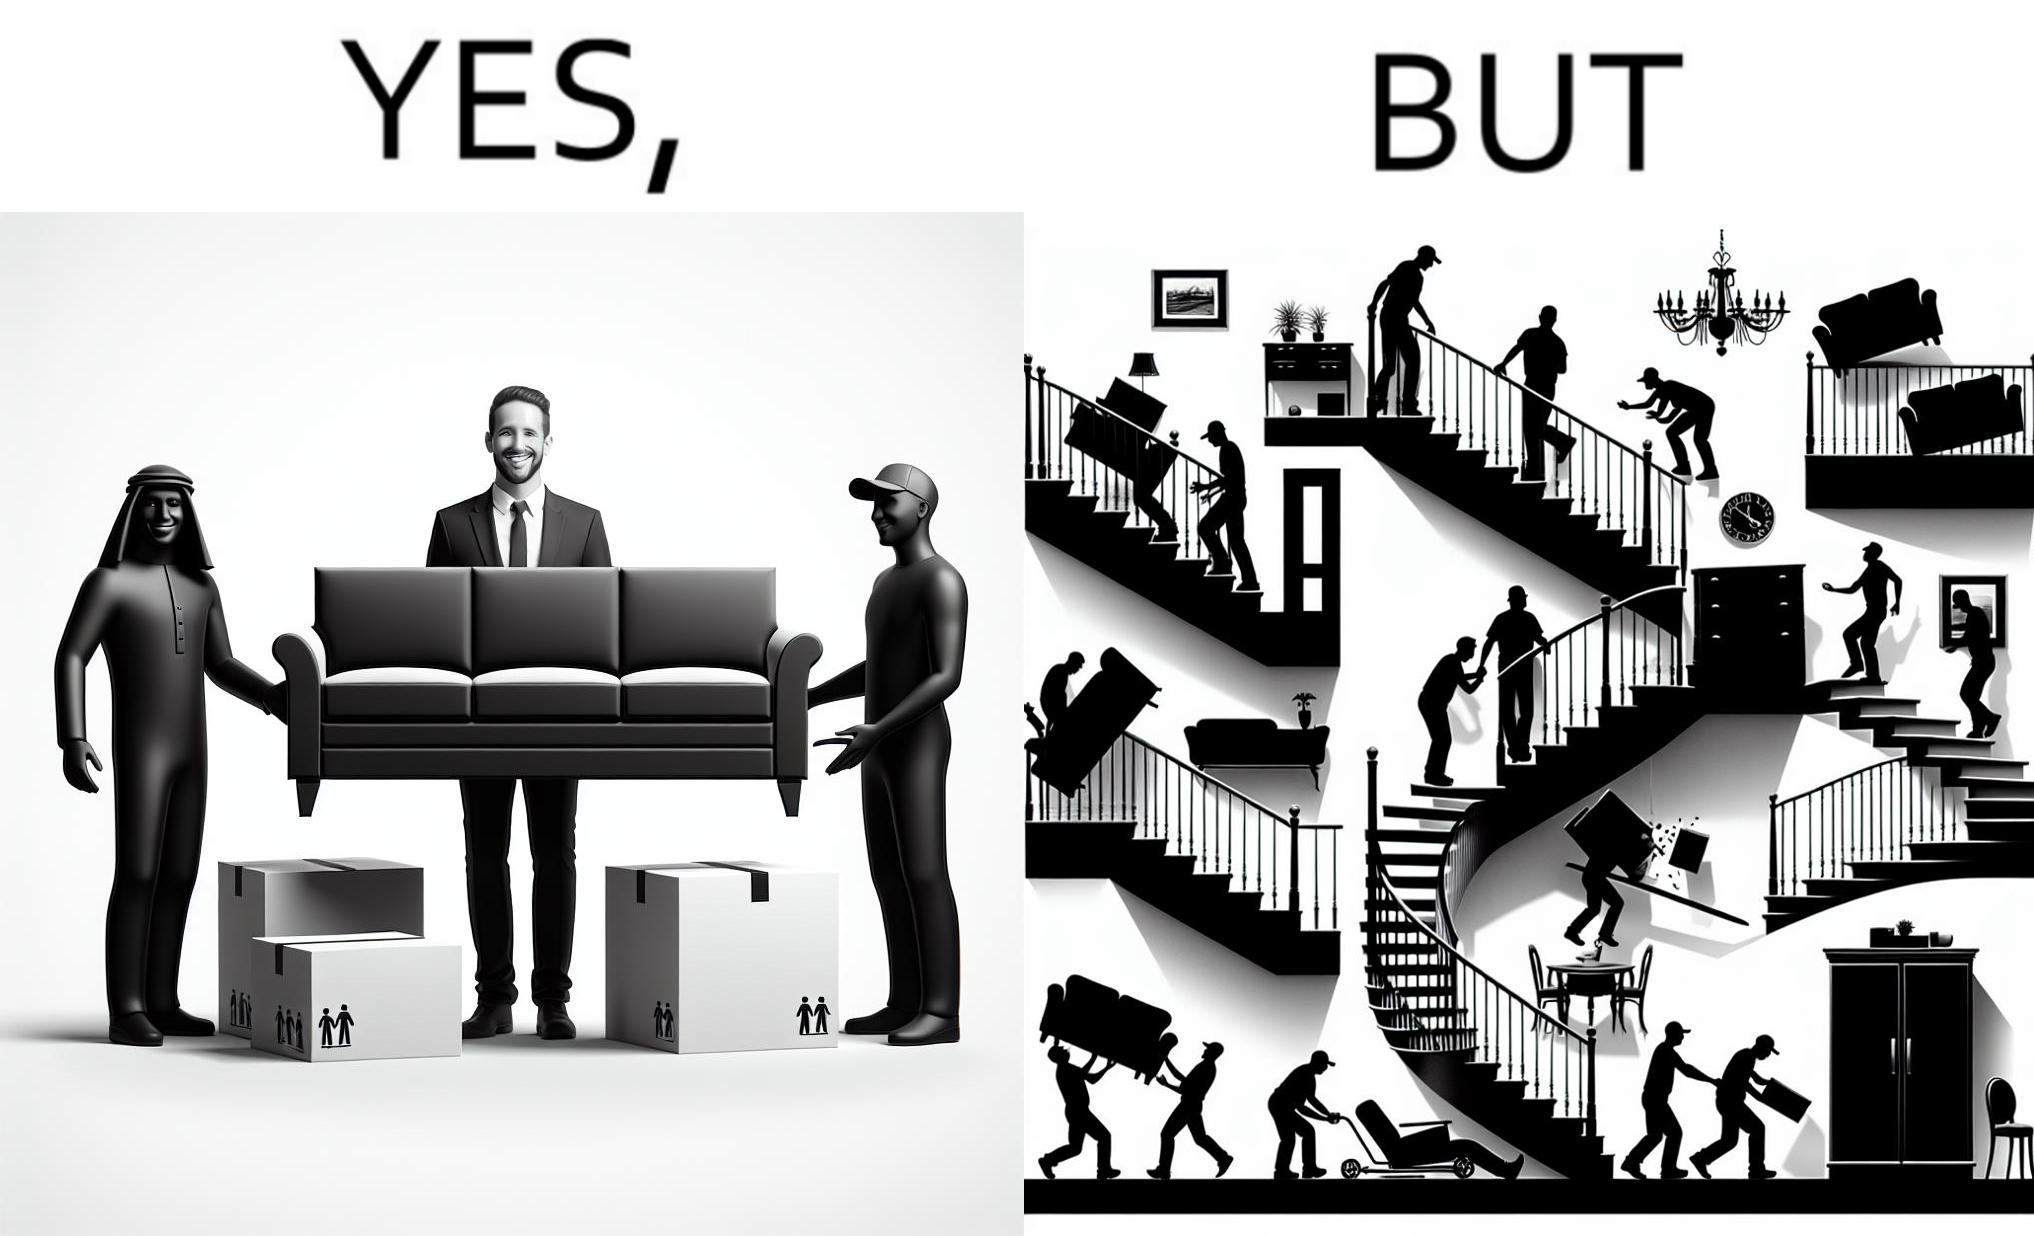Explain the humor or irony in this image. The images are funny since they show how even though the hired movers achieve their task of moving in furniture, in the process, the cause damage to the whole house 